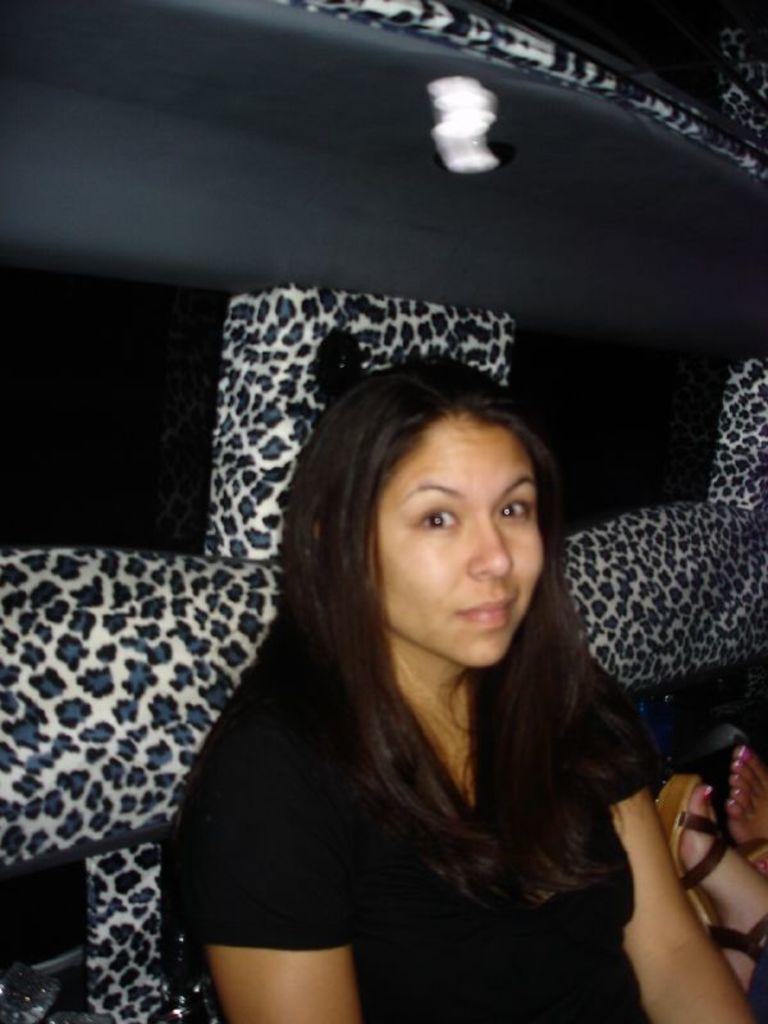Please provide a concise description of this image. In this picture I see a woman who is wearing black dress and in the background I see the black and white color thing and on the right side of this image I see the legs of a person. 